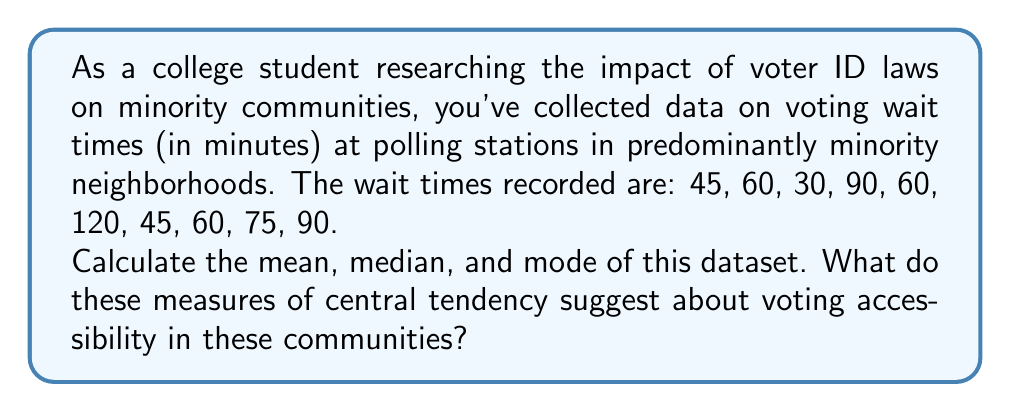Solve this math problem. Let's calculate the mean, median, and mode step by step:

1. Mean:
   The mean is the average of all values.
   
   $$\text{Mean} = \frac{\text{Sum of all values}}{\text{Number of values}}$$
   
   Sum of values: $45 + 60 + 30 + 90 + 60 + 120 + 45 + 60 + 75 + 90 = 675$
   Number of values: $10$
   
   $$\text{Mean} = \frac{675}{10} = 67.5$$

2. Median:
   The median is the middle value when the dataset is ordered.
   
   Ordered dataset: $30, 45, 45, 60, 60, 60, 75, 90, 90, 120$
   
   With 10 values, we take the average of the 5th and 6th values:
   
   $$\text{Median} = \frac{60 + 60}{2} = 60$$

3. Mode:
   The mode is the most frequently occurring value.
   
   In this dataset, 60 appears three times, more than any other value.
   
   $$\text{Mode} = 60$$

These measures suggest that voters in these communities face significant wait times. The mean of 67.5 minutes indicates a high average wait time. The median of 60 minutes shows that half of the voters wait an hour or more. The mode of 60 minutes being the most common wait time further emphasizes the prevalence of long waits. This data could support the argument that these communities face disproportionate barriers to voting, which may be exacerbated by voter ID laws.
Answer: Mean: 67.5 minutes
Median: 60 minutes
Mode: 60 minutes 